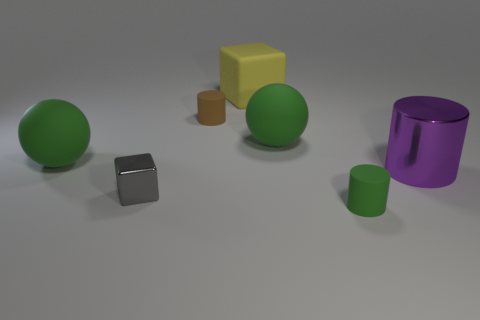Add 2 yellow metal spheres. How many objects exist? 9 Subtract all blocks. How many objects are left? 5 Subtract all gray blocks. Subtract all big green matte balls. How many objects are left? 4 Add 7 blocks. How many blocks are left? 9 Add 3 big rubber objects. How many big rubber objects exist? 6 Subtract 0 gray spheres. How many objects are left? 7 